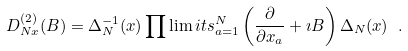Convert formula to latex. <formula><loc_0><loc_0><loc_500><loc_500>D _ { N x } ^ { ( 2 ) } ( B ) = \Delta _ { N } ^ { - 1 } ( x ) \prod \lim i t s _ { a = 1 } ^ { N } \left ( \frac { \partial } { \partial x _ { a } } + \imath B \right ) \Delta _ { N } ( x ) \ .</formula> 